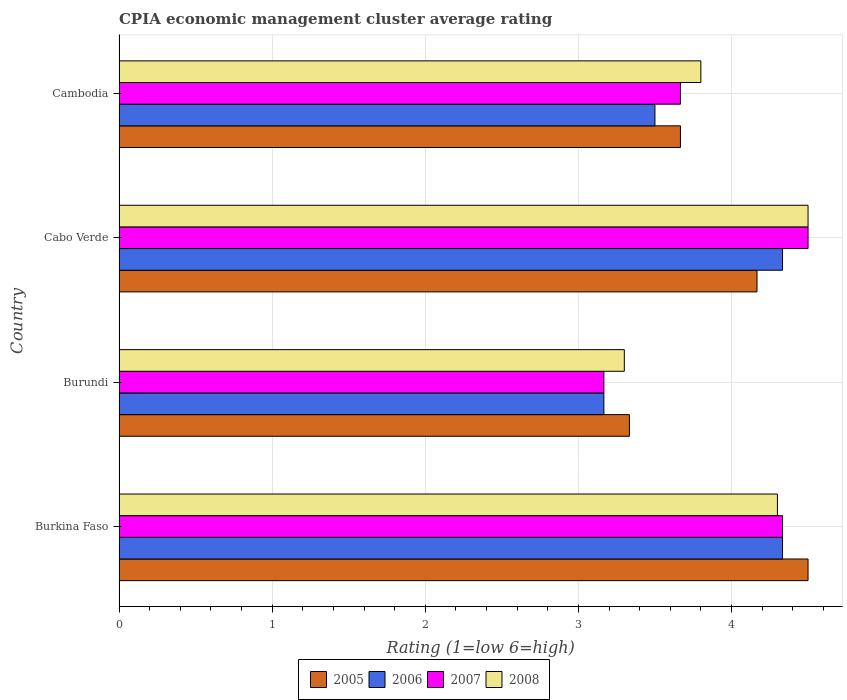How many groups of bars are there?
Provide a succinct answer. 4. How many bars are there on the 1st tick from the bottom?
Offer a very short reply. 4. What is the label of the 1st group of bars from the top?
Provide a short and direct response. Cambodia. What is the CPIA rating in 2008 in Cambodia?
Keep it short and to the point. 3.8. Across all countries, what is the maximum CPIA rating in 2007?
Give a very brief answer. 4.5. Across all countries, what is the minimum CPIA rating in 2007?
Your answer should be very brief. 3.17. In which country was the CPIA rating in 2007 maximum?
Give a very brief answer. Cabo Verde. In which country was the CPIA rating in 2005 minimum?
Your answer should be compact. Burundi. What is the total CPIA rating in 2007 in the graph?
Your response must be concise. 15.67. What is the difference between the CPIA rating in 2005 in Burkina Faso and that in Cambodia?
Make the answer very short. 0.83. What is the average CPIA rating in 2005 per country?
Your answer should be compact. 3.92. What is the difference between the CPIA rating in 2008 and CPIA rating in 2005 in Cabo Verde?
Ensure brevity in your answer.  0.33. What is the ratio of the CPIA rating in 2007 in Burkina Faso to that in Cambodia?
Your answer should be very brief. 1.18. Is the CPIA rating in 2007 in Cabo Verde less than that in Cambodia?
Make the answer very short. No. What is the difference between the highest and the second highest CPIA rating in 2008?
Provide a short and direct response. 0.2. What is the difference between the highest and the lowest CPIA rating in 2007?
Keep it short and to the point. 1.33. In how many countries, is the CPIA rating in 2007 greater than the average CPIA rating in 2007 taken over all countries?
Ensure brevity in your answer.  2. Is it the case that in every country, the sum of the CPIA rating in 2006 and CPIA rating in 2005 is greater than the CPIA rating in 2007?
Your response must be concise. Yes. How many bars are there?
Your response must be concise. 16. Are all the bars in the graph horizontal?
Provide a short and direct response. Yes. How many countries are there in the graph?
Make the answer very short. 4. Does the graph contain any zero values?
Provide a succinct answer. No. Does the graph contain grids?
Your response must be concise. Yes. How many legend labels are there?
Make the answer very short. 4. How are the legend labels stacked?
Your answer should be very brief. Horizontal. What is the title of the graph?
Your response must be concise. CPIA economic management cluster average rating. What is the label or title of the X-axis?
Keep it short and to the point. Rating (1=low 6=high). What is the label or title of the Y-axis?
Make the answer very short. Country. What is the Rating (1=low 6=high) in 2006 in Burkina Faso?
Keep it short and to the point. 4.33. What is the Rating (1=low 6=high) of 2007 in Burkina Faso?
Keep it short and to the point. 4.33. What is the Rating (1=low 6=high) in 2008 in Burkina Faso?
Ensure brevity in your answer.  4.3. What is the Rating (1=low 6=high) in 2005 in Burundi?
Your answer should be compact. 3.33. What is the Rating (1=low 6=high) of 2006 in Burundi?
Provide a succinct answer. 3.17. What is the Rating (1=low 6=high) of 2007 in Burundi?
Give a very brief answer. 3.17. What is the Rating (1=low 6=high) of 2005 in Cabo Verde?
Make the answer very short. 4.17. What is the Rating (1=low 6=high) of 2006 in Cabo Verde?
Your response must be concise. 4.33. What is the Rating (1=low 6=high) of 2007 in Cabo Verde?
Keep it short and to the point. 4.5. What is the Rating (1=low 6=high) in 2008 in Cabo Verde?
Your response must be concise. 4.5. What is the Rating (1=low 6=high) of 2005 in Cambodia?
Offer a very short reply. 3.67. What is the Rating (1=low 6=high) in 2006 in Cambodia?
Make the answer very short. 3.5. What is the Rating (1=low 6=high) of 2007 in Cambodia?
Offer a terse response. 3.67. Across all countries, what is the maximum Rating (1=low 6=high) of 2005?
Your answer should be compact. 4.5. Across all countries, what is the maximum Rating (1=low 6=high) of 2006?
Ensure brevity in your answer.  4.33. Across all countries, what is the maximum Rating (1=low 6=high) of 2008?
Offer a very short reply. 4.5. Across all countries, what is the minimum Rating (1=low 6=high) in 2005?
Make the answer very short. 3.33. Across all countries, what is the minimum Rating (1=low 6=high) of 2006?
Offer a very short reply. 3.17. Across all countries, what is the minimum Rating (1=low 6=high) of 2007?
Your answer should be very brief. 3.17. What is the total Rating (1=low 6=high) of 2005 in the graph?
Provide a succinct answer. 15.67. What is the total Rating (1=low 6=high) of 2006 in the graph?
Provide a succinct answer. 15.33. What is the total Rating (1=low 6=high) in 2007 in the graph?
Your answer should be very brief. 15.67. What is the total Rating (1=low 6=high) in 2008 in the graph?
Offer a terse response. 15.9. What is the difference between the Rating (1=low 6=high) in 2005 in Burkina Faso and that in Burundi?
Provide a succinct answer. 1.17. What is the difference between the Rating (1=low 6=high) of 2005 in Burkina Faso and that in Cabo Verde?
Give a very brief answer. 0.33. What is the difference between the Rating (1=low 6=high) in 2006 in Burkina Faso and that in Cabo Verde?
Ensure brevity in your answer.  0. What is the difference between the Rating (1=low 6=high) of 2007 in Burkina Faso and that in Cabo Verde?
Your response must be concise. -0.17. What is the difference between the Rating (1=low 6=high) in 2007 in Burkina Faso and that in Cambodia?
Your answer should be compact. 0.67. What is the difference between the Rating (1=low 6=high) of 2006 in Burundi and that in Cabo Verde?
Give a very brief answer. -1.17. What is the difference between the Rating (1=low 6=high) of 2007 in Burundi and that in Cabo Verde?
Provide a short and direct response. -1.33. What is the difference between the Rating (1=low 6=high) in 2005 in Burundi and that in Cambodia?
Ensure brevity in your answer.  -0.33. What is the difference between the Rating (1=low 6=high) in 2006 in Burundi and that in Cambodia?
Offer a terse response. -0.33. What is the difference between the Rating (1=low 6=high) of 2007 in Burundi and that in Cambodia?
Make the answer very short. -0.5. What is the difference between the Rating (1=low 6=high) in 2007 in Cabo Verde and that in Cambodia?
Offer a terse response. 0.83. What is the difference between the Rating (1=low 6=high) of 2005 in Burkina Faso and the Rating (1=low 6=high) of 2006 in Burundi?
Ensure brevity in your answer.  1.33. What is the difference between the Rating (1=low 6=high) of 2005 in Burkina Faso and the Rating (1=low 6=high) of 2008 in Burundi?
Offer a terse response. 1.2. What is the difference between the Rating (1=low 6=high) of 2006 in Burkina Faso and the Rating (1=low 6=high) of 2007 in Burundi?
Provide a short and direct response. 1.17. What is the difference between the Rating (1=low 6=high) in 2007 in Burkina Faso and the Rating (1=low 6=high) in 2008 in Burundi?
Make the answer very short. 1.03. What is the difference between the Rating (1=low 6=high) of 2005 in Burkina Faso and the Rating (1=low 6=high) of 2007 in Cabo Verde?
Your answer should be very brief. 0. What is the difference between the Rating (1=low 6=high) of 2005 in Burkina Faso and the Rating (1=low 6=high) of 2008 in Cabo Verde?
Your answer should be very brief. 0. What is the difference between the Rating (1=low 6=high) in 2005 in Burkina Faso and the Rating (1=low 6=high) in 2008 in Cambodia?
Give a very brief answer. 0.7. What is the difference between the Rating (1=low 6=high) of 2006 in Burkina Faso and the Rating (1=low 6=high) of 2008 in Cambodia?
Give a very brief answer. 0.53. What is the difference between the Rating (1=low 6=high) in 2007 in Burkina Faso and the Rating (1=low 6=high) in 2008 in Cambodia?
Keep it short and to the point. 0.53. What is the difference between the Rating (1=low 6=high) in 2005 in Burundi and the Rating (1=low 6=high) in 2006 in Cabo Verde?
Your answer should be very brief. -1. What is the difference between the Rating (1=low 6=high) in 2005 in Burundi and the Rating (1=low 6=high) in 2007 in Cabo Verde?
Your response must be concise. -1.17. What is the difference between the Rating (1=low 6=high) in 2005 in Burundi and the Rating (1=low 6=high) in 2008 in Cabo Verde?
Offer a very short reply. -1.17. What is the difference between the Rating (1=low 6=high) of 2006 in Burundi and the Rating (1=low 6=high) of 2007 in Cabo Verde?
Your answer should be compact. -1.33. What is the difference between the Rating (1=low 6=high) in 2006 in Burundi and the Rating (1=low 6=high) in 2008 in Cabo Verde?
Your answer should be very brief. -1.33. What is the difference between the Rating (1=low 6=high) of 2007 in Burundi and the Rating (1=low 6=high) of 2008 in Cabo Verde?
Offer a terse response. -1.33. What is the difference between the Rating (1=low 6=high) in 2005 in Burundi and the Rating (1=low 6=high) in 2008 in Cambodia?
Keep it short and to the point. -0.47. What is the difference between the Rating (1=low 6=high) of 2006 in Burundi and the Rating (1=low 6=high) of 2007 in Cambodia?
Ensure brevity in your answer.  -0.5. What is the difference between the Rating (1=low 6=high) of 2006 in Burundi and the Rating (1=low 6=high) of 2008 in Cambodia?
Offer a very short reply. -0.63. What is the difference between the Rating (1=low 6=high) in 2007 in Burundi and the Rating (1=low 6=high) in 2008 in Cambodia?
Make the answer very short. -0.63. What is the difference between the Rating (1=low 6=high) of 2005 in Cabo Verde and the Rating (1=low 6=high) of 2007 in Cambodia?
Your answer should be compact. 0.5. What is the difference between the Rating (1=low 6=high) in 2005 in Cabo Verde and the Rating (1=low 6=high) in 2008 in Cambodia?
Offer a very short reply. 0.37. What is the difference between the Rating (1=low 6=high) of 2006 in Cabo Verde and the Rating (1=low 6=high) of 2007 in Cambodia?
Provide a short and direct response. 0.67. What is the difference between the Rating (1=low 6=high) in 2006 in Cabo Verde and the Rating (1=low 6=high) in 2008 in Cambodia?
Offer a very short reply. 0.53. What is the average Rating (1=low 6=high) of 2005 per country?
Provide a short and direct response. 3.92. What is the average Rating (1=low 6=high) in 2006 per country?
Your response must be concise. 3.83. What is the average Rating (1=low 6=high) of 2007 per country?
Provide a succinct answer. 3.92. What is the average Rating (1=low 6=high) in 2008 per country?
Ensure brevity in your answer.  3.98. What is the difference between the Rating (1=low 6=high) of 2005 and Rating (1=low 6=high) of 2008 in Burkina Faso?
Ensure brevity in your answer.  0.2. What is the difference between the Rating (1=low 6=high) of 2006 and Rating (1=low 6=high) of 2007 in Burkina Faso?
Your answer should be very brief. 0. What is the difference between the Rating (1=low 6=high) in 2005 and Rating (1=low 6=high) in 2006 in Burundi?
Your answer should be very brief. 0.17. What is the difference between the Rating (1=low 6=high) in 2005 and Rating (1=low 6=high) in 2007 in Burundi?
Provide a short and direct response. 0.17. What is the difference between the Rating (1=low 6=high) of 2006 and Rating (1=low 6=high) of 2007 in Burundi?
Provide a succinct answer. 0. What is the difference between the Rating (1=low 6=high) in 2006 and Rating (1=low 6=high) in 2008 in Burundi?
Make the answer very short. -0.13. What is the difference between the Rating (1=low 6=high) in 2007 and Rating (1=low 6=high) in 2008 in Burundi?
Provide a succinct answer. -0.13. What is the difference between the Rating (1=low 6=high) of 2005 and Rating (1=low 6=high) of 2006 in Cabo Verde?
Provide a short and direct response. -0.17. What is the difference between the Rating (1=low 6=high) of 2005 and Rating (1=low 6=high) of 2008 in Cabo Verde?
Offer a terse response. -0.33. What is the difference between the Rating (1=low 6=high) in 2006 and Rating (1=low 6=high) in 2007 in Cabo Verde?
Your answer should be very brief. -0.17. What is the difference between the Rating (1=low 6=high) in 2006 and Rating (1=low 6=high) in 2008 in Cabo Verde?
Keep it short and to the point. -0.17. What is the difference between the Rating (1=low 6=high) in 2007 and Rating (1=low 6=high) in 2008 in Cabo Verde?
Your answer should be very brief. 0. What is the difference between the Rating (1=low 6=high) in 2005 and Rating (1=low 6=high) in 2007 in Cambodia?
Your answer should be compact. 0. What is the difference between the Rating (1=low 6=high) in 2005 and Rating (1=low 6=high) in 2008 in Cambodia?
Your answer should be compact. -0.13. What is the difference between the Rating (1=low 6=high) in 2006 and Rating (1=low 6=high) in 2007 in Cambodia?
Provide a succinct answer. -0.17. What is the difference between the Rating (1=low 6=high) of 2007 and Rating (1=low 6=high) of 2008 in Cambodia?
Give a very brief answer. -0.13. What is the ratio of the Rating (1=low 6=high) in 2005 in Burkina Faso to that in Burundi?
Offer a terse response. 1.35. What is the ratio of the Rating (1=low 6=high) in 2006 in Burkina Faso to that in Burundi?
Your answer should be very brief. 1.37. What is the ratio of the Rating (1=low 6=high) of 2007 in Burkina Faso to that in Burundi?
Provide a short and direct response. 1.37. What is the ratio of the Rating (1=low 6=high) in 2008 in Burkina Faso to that in Burundi?
Ensure brevity in your answer.  1.3. What is the ratio of the Rating (1=low 6=high) in 2005 in Burkina Faso to that in Cabo Verde?
Ensure brevity in your answer.  1.08. What is the ratio of the Rating (1=low 6=high) in 2007 in Burkina Faso to that in Cabo Verde?
Give a very brief answer. 0.96. What is the ratio of the Rating (1=low 6=high) in 2008 in Burkina Faso to that in Cabo Verde?
Make the answer very short. 0.96. What is the ratio of the Rating (1=low 6=high) of 2005 in Burkina Faso to that in Cambodia?
Provide a succinct answer. 1.23. What is the ratio of the Rating (1=low 6=high) of 2006 in Burkina Faso to that in Cambodia?
Provide a short and direct response. 1.24. What is the ratio of the Rating (1=low 6=high) in 2007 in Burkina Faso to that in Cambodia?
Ensure brevity in your answer.  1.18. What is the ratio of the Rating (1=low 6=high) of 2008 in Burkina Faso to that in Cambodia?
Make the answer very short. 1.13. What is the ratio of the Rating (1=low 6=high) in 2006 in Burundi to that in Cabo Verde?
Offer a terse response. 0.73. What is the ratio of the Rating (1=low 6=high) of 2007 in Burundi to that in Cabo Verde?
Provide a short and direct response. 0.7. What is the ratio of the Rating (1=low 6=high) of 2008 in Burundi to that in Cabo Verde?
Give a very brief answer. 0.73. What is the ratio of the Rating (1=low 6=high) in 2005 in Burundi to that in Cambodia?
Provide a short and direct response. 0.91. What is the ratio of the Rating (1=low 6=high) of 2006 in Burundi to that in Cambodia?
Keep it short and to the point. 0.9. What is the ratio of the Rating (1=low 6=high) of 2007 in Burundi to that in Cambodia?
Offer a terse response. 0.86. What is the ratio of the Rating (1=low 6=high) of 2008 in Burundi to that in Cambodia?
Provide a short and direct response. 0.87. What is the ratio of the Rating (1=low 6=high) in 2005 in Cabo Verde to that in Cambodia?
Provide a succinct answer. 1.14. What is the ratio of the Rating (1=low 6=high) of 2006 in Cabo Verde to that in Cambodia?
Ensure brevity in your answer.  1.24. What is the ratio of the Rating (1=low 6=high) of 2007 in Cabo Verde to that in Cambodia?
Make the answer very short. 1.23. What is the ratio of the Rating (1=low 6=high) of 2008 in Cabo Verde to that in Cambodia?
Make the answer very short. 1.18. What is the difference between the highest and the second highest Rating (1=low 6=high) in 2006?
Provide a succinct answer. 0. What is the difference between the highest and the lowest Rating (1=low 6=high) in 2005?
Make the answer very short. 1.17. What is the difference between the highest and the lowest Rating (1=low 6=high) of 2006?
Keep it short and to the point. 1.17. What is the difference between the highest and the lowest Rating (1=low 6=high) in 2007?
Your answer should be compact. 1.33. 